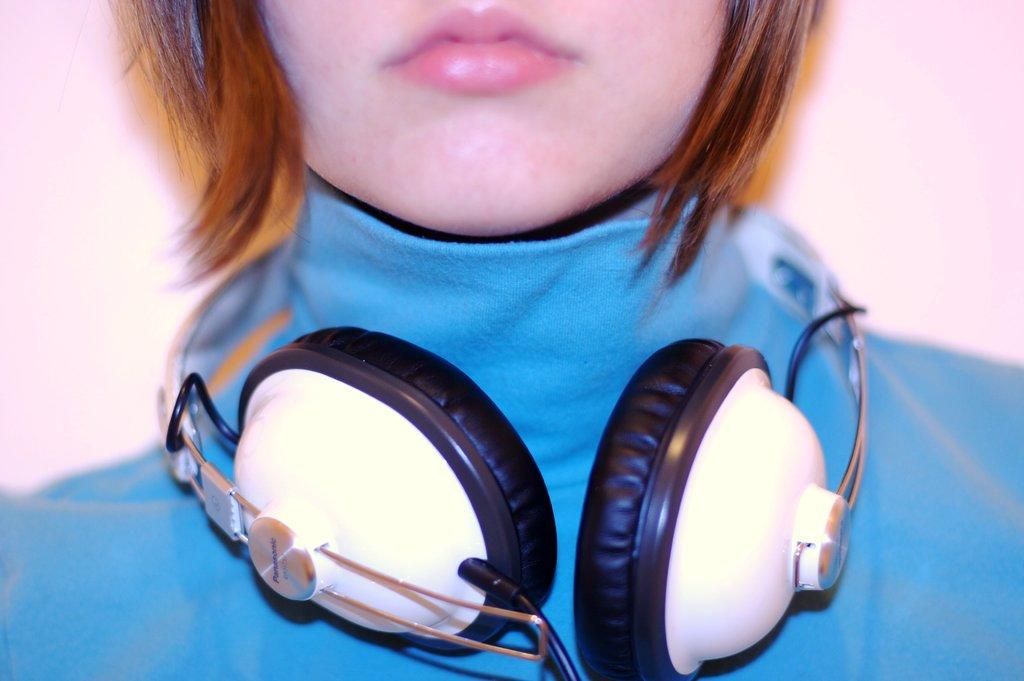Who is the main subject in the image? There is a woman in the image. What is the woman wearing? The woman is wearing a blue dress and headphones around her neck. What color is the background of the image? The background of the image is pink. What type of shade does the woman use to protect herself from the sun in the image? There is no shade present in the image, and the woman is not using any to protect herself from the sun. 